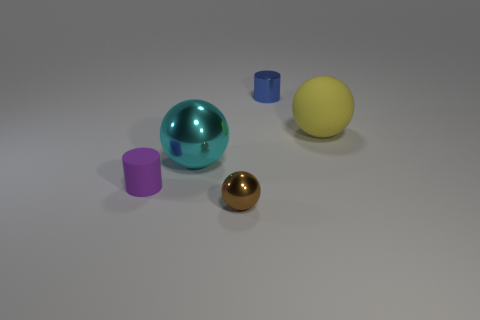Add 2 tiny green balls. How many objects exist? 7 Subtract all cylinders. How many objects are left? 3 Add 3 small red metallic spheres. How many small red metallic spheres exist? 3 Subtract 0 green blocks. How many objects are left? 5 Subtract all rubber balls. Subtract all tiny cylinders. How many objects are left? 2 Add 5 small blue things. How many small blue things are left? 6 